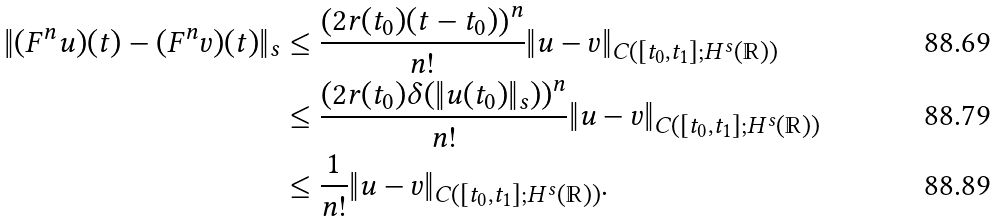<formula> <loc_0><loc_0><loc_500><loc_500>\| ( F ^ { n } u ) ( t ) - ( F ^ { n } v ) ( t ) \| _ { s } & \leq \frac { \left ( 2 r ( t _ { 0 } ) ( t - t _ { 0 } ) \right ) ^ { n } } { n ! } \| u - v \| _ { C ( [ t _ { 0 } , t _ { 1 } ] ; H ^ { s } ( \mathbb { R } ) ) } \\ & \leq \frac { \left ( 2 r ( t _ { 0 } ) \delta ( \| u ( t _ { 0 } ) \| _ { s } ) \right ) ^ { n } } { n ! } \| u - v \| _ { C ( [ t _ { 0 } , t _ { 1 } ] ; H ^ { s } ( \mathbb { R } ) ) } \\ & \leq \frac { 1 } { n ! } \| u - v \| _ { C ( [ t _ { 0 } , t _ { 1 } ] ; H ^ { s } ( \mathbb { R } ) ) } .</formula> 